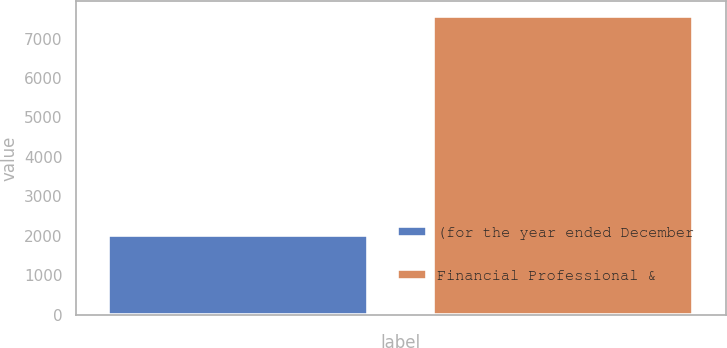Convert chart. <chart><loc_0><loc_0><loc_500><loc_500><bar_chart><fcel>(for the year ended December<fcel>Financial Professional &<nl><fcel>2010<fcel>7567<nl></chart> 